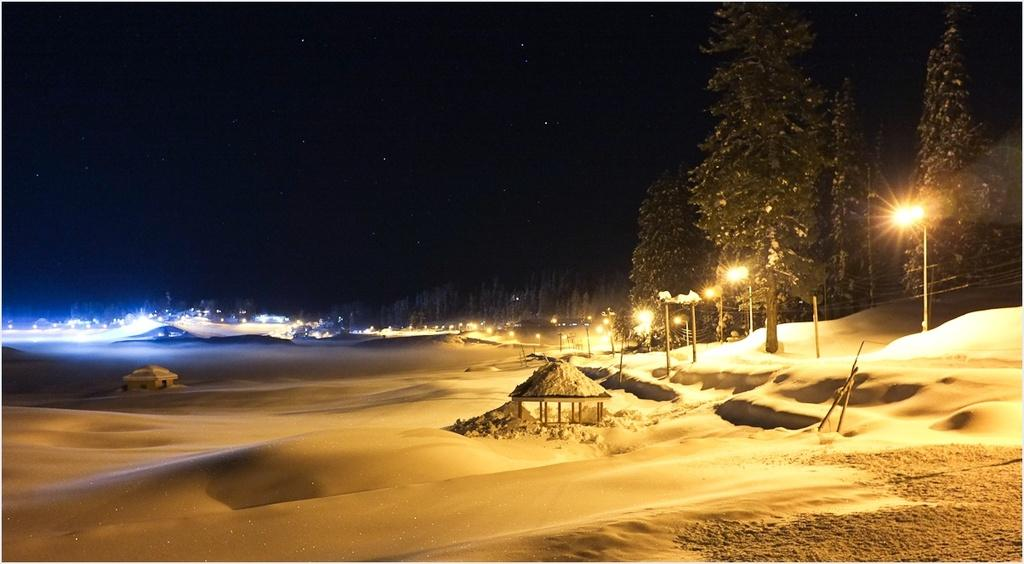What structures are located in the center of the image? There are shelters in the center of the image. What type of vegetation is on the right side of the image? There are trees on the right side of the image. What type of objects provide illumination in the image? There are light poles and lights in the image. What can be seen in the background of the image? There are trees and lights in the background of the image. What sense is being taught in the image? There is no teaching or learning activity depicted in the image. What type of hook is attached to the trees in the image? There are no hooks present in the image; only shelters, trees, light poles, and lights are visible. 